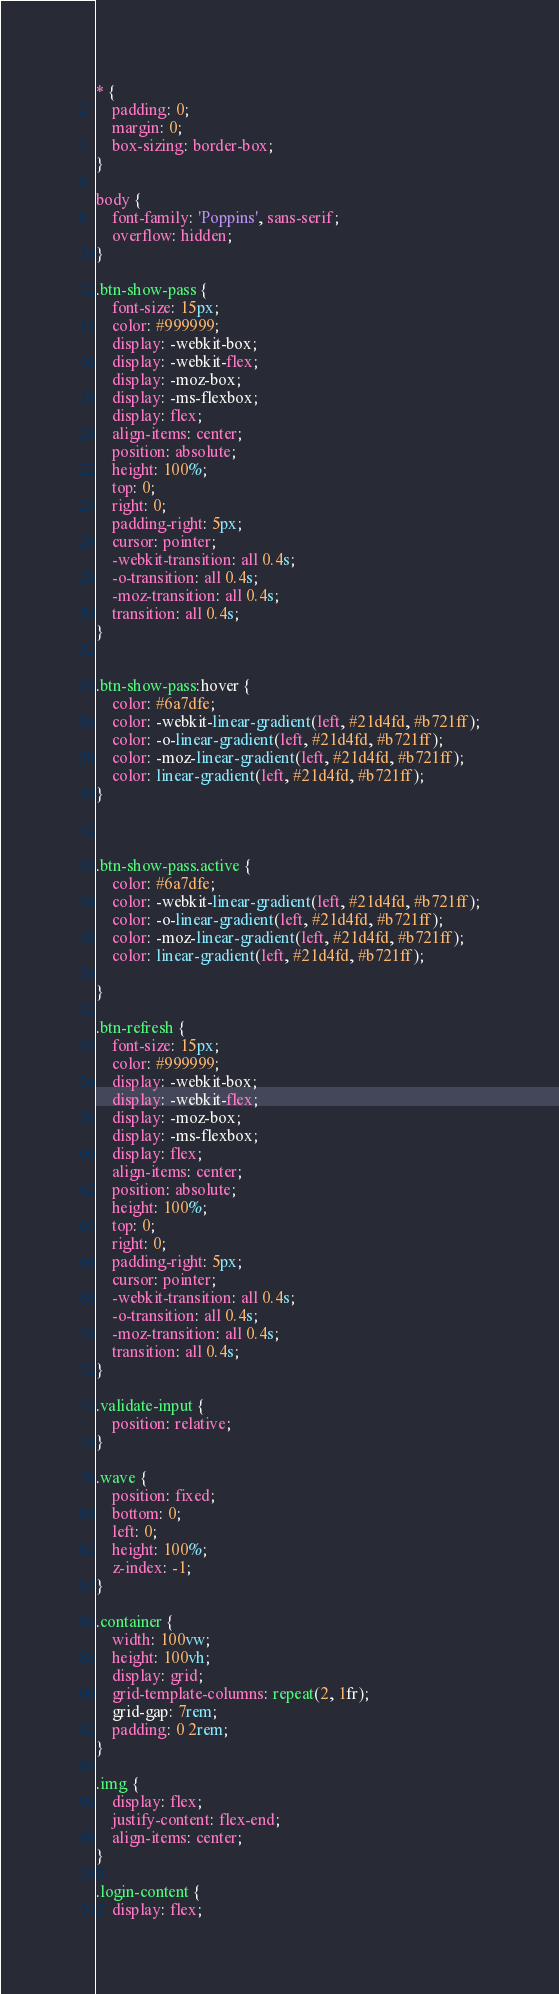Convert code to text. <code><loc_0><loc_0><loc_500><loc_500><_CSS_>* {
	padding: 0;
	margin: 0;
	box-sizing: border-box;
}

body {
	font-family: 'Poppins', sans-serif;
	overflow: hidden;
}

.btn-show-pass {
	font-size: 15px;
	color: #999999;
	display: -webkit-box;
	display: -webkit-flex;
	display: -moz-box;
	display: -ms-flexbox;
	display: flex;
	align-items: center;
	position: absolute;
	height: 100%;
	top: 0;
	right: 0;
	padding-right: 5px;
	cursor: pointer;
	-webkit-transition: all 0.4s;
	-o-transition: all 0.4s;
	-moz-transition: all 0.4s;
	transition: all 0.4s;
}


.btn-show-pass:hover {
	color: #6a7dfe;
	color: -webkit-linear-gradient(left, #21d4fd, #b721ff);
	color: -o-linear-gradient(left, #21d4fd, #b721ff);
	color: -moz-linear-gradient(left, #21d4fd, #b721ff);
	color: linear-gradient(left, #21d4fd, #b721ff);
}



.btn-show-pass.active {
	color: #6a7dfe;
	color: -webkit-linear-gradient(left, #21d4fd, #b721ff);
	color: -o-linear-gradient(left, #21d4fd, #b721ff);
	color: -moz-linear-gradient(left, #21d4fd, #b721ff);
	color: linear-gradient(left, #21d4fd, #b721ff);

}

.btn-refresh {
	font-size: 15px;
	color: #999999;
	display: -webkit-box;
	display: -webkit-flex;
	display: -moz-box;
	display: -ms-flexbox;
	display: flex;
	align-items: center;
	position: absolute;
	height: 100%;
	top: 0;
	right: 0;
	padding-right: 5px;
	cursor: pointer;
	-webkit-transition: all 0.4s;
	-o-transition: all 0.4s;
	-moz-transition: all 0.4s;
	transition: all 0.4s;
}

.validate-input {
	position: relative;
}

.wave {
	position: fixed;
	bottom: 0;
	left: 0;
	height: 100%;
	z-index: -1;
}

.container {
	width: 100vw;
	height: 100vh;
	display: grid;
	grid-template-columns: repeat(2, 1fr);
	grid-gap: 7rem;
	padding: 0 2rem;
}

.img {
	display: flex;
	justify-content: flex-end;
	align-items: center;
}

.login-content {
	display: flex;</code> 